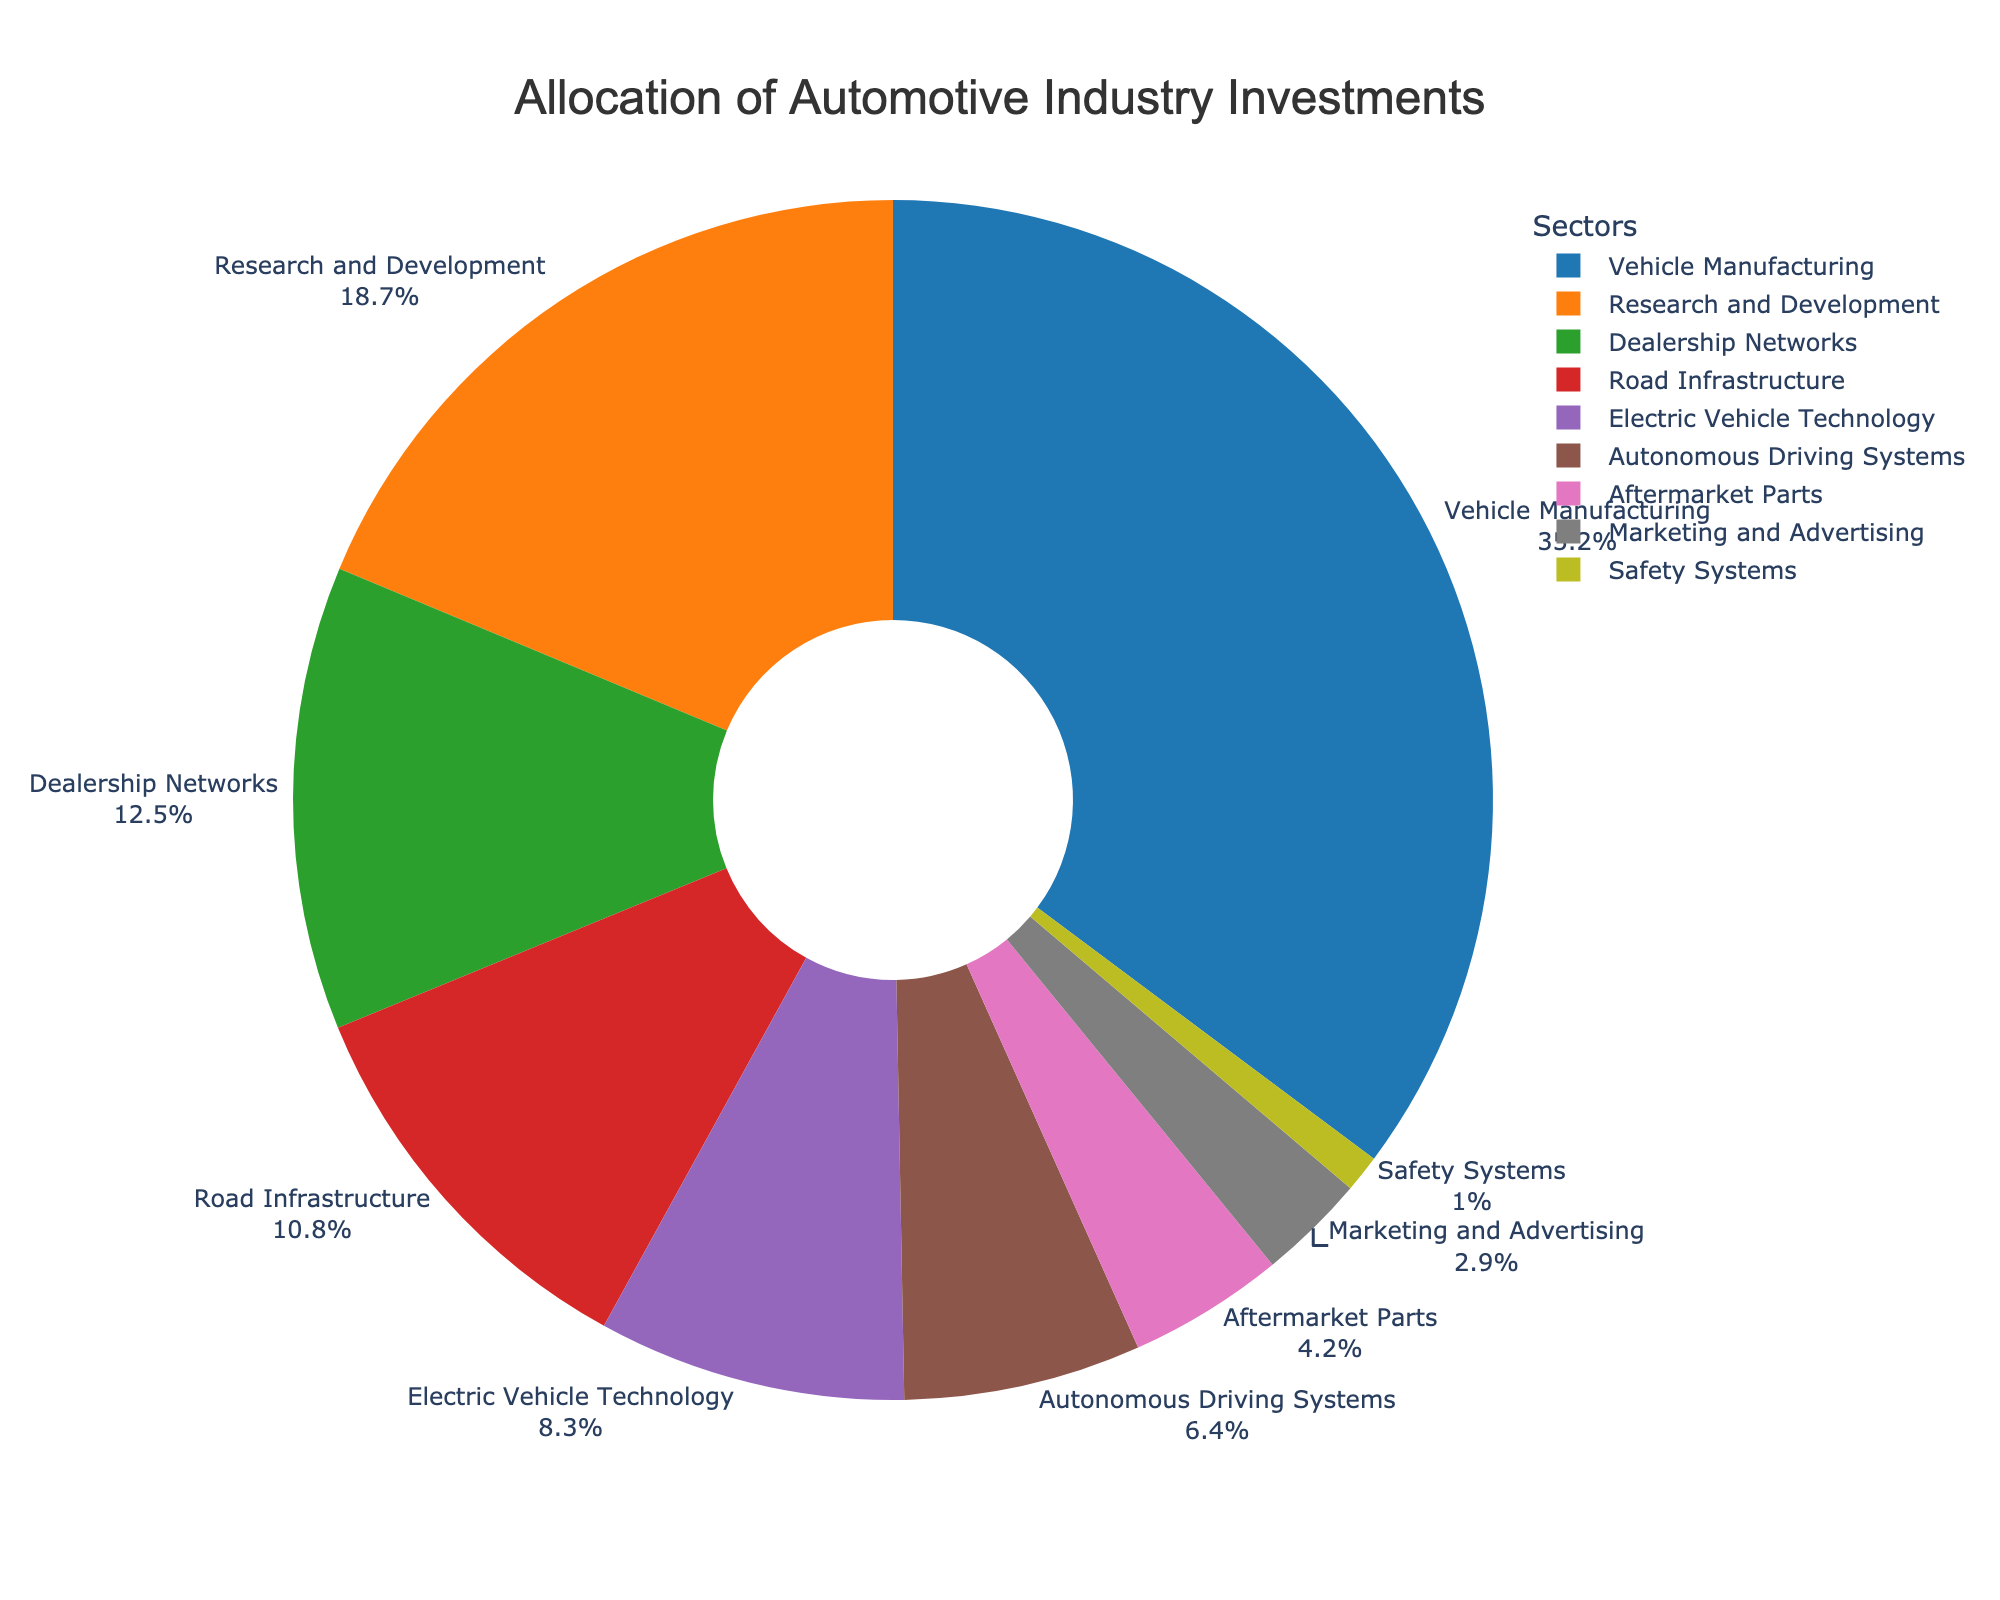What's the sector with the highest investment percentage? The figure shows a pie chart divided into different sectors. The sector labeled "Vehicle Manufacturing" has the largest section, indicating it has the highest investment percentage.
Answer: Vehicle Manufacturing Which investment categories together make up more than 50% of the total investment? Checking the largest sections, we sum Vehicle Manufacturing (35.2%), Research and Development (18.7%), and note it exceeds 50%.
Answer: Vehicle Manufacturing and Research and Development How does the investment in Road Infrastructure compare to that in Dealership Networks? The pie chart shows Road Infrastructure at 10.8% and Dealership Networks at 12.5%. Comparing these values, Dealership Networks have a higher percentage.
Answer: Dealership Networks are more What's the combined investment percentage for Electric Vehicle Technology and Autonomous Driving Systems? Adding percentages for Electric Vehicle Technology (8.3%) and Autonomous Driving Systems (6.4%) gives us 8.3 + 6.4 = 14.7%.
Answer: 14.7% How much less is the investment in Safety Systems compared to Vehicle Manufacturing? Subtracting Safety Systems (1.0%) from Vehicle Manufacturing (35.2%) gives 35.2 - 1.0 = 34.2%.
Answer: 34.2% If we group Road Infrastructure, Aftermarket Parts, and Safety Systems together, what percentage of the total investment do they constitute? Summing Road Infrastructure (10.8%), Aftermarket Parts (4.2%), and Safety Systems (1.0%) results in 10.8 + 4.2 + 1.0 = 16.0%.
Answer: 16.0% What proportion of the investment is allocated to marketing-related activities (e.g., Marketing and Advertising)? The chart shows Marketing and Advertising with a 2.9% allocation.
Answer: 2.9% Which sector has a higher investment, Electric Vehicle Technology or Autonomous Driving Systems? The pie chart shows Electric Vehicle Technology at 8.3% and Autonomous Driving Systems at 6.4%. Therefore, Electric Vehicle Technology has a higher investment.
Answer: Electric Vehicle Technology What is the third largest investment sector after Vehicle Manufacturing and Research and Development? The largest is Vehicle Manufacturing (35.2%), followed by Research and Development (18.7%). The next largest is Dealership Networks at 12.5%.
Answer: Dealership Networks If Safety Systems investment were doubled, what would its new percentage be? Doubling the current percentage of Safety Systems (1.0%) gives 1.0 * 2 = 2.0%.
Answer: 2.0% 